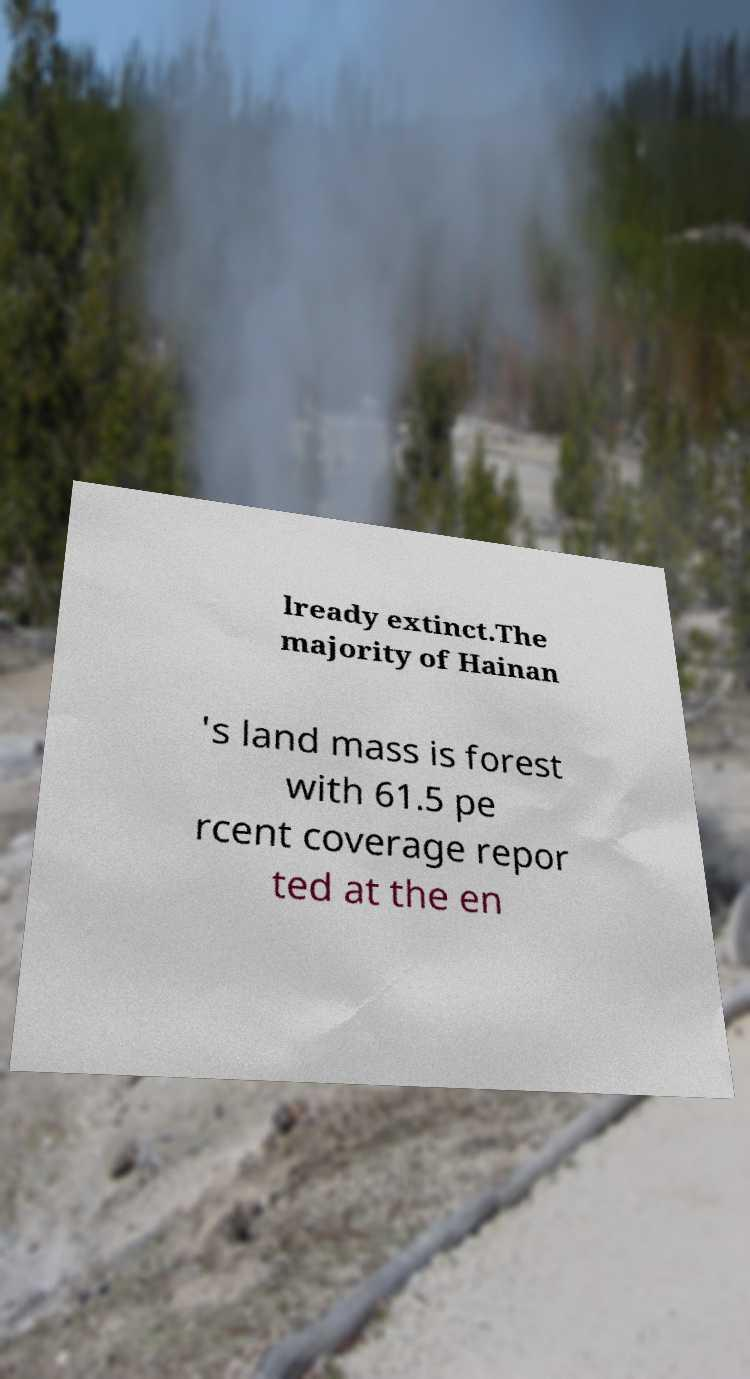For documentation purposes, I need the text within this image transcribed. Could you provide that? lready extinct.The majority of Hainan 's land mass is forest with 61.5 pe rcent coverage repor ted at the en 